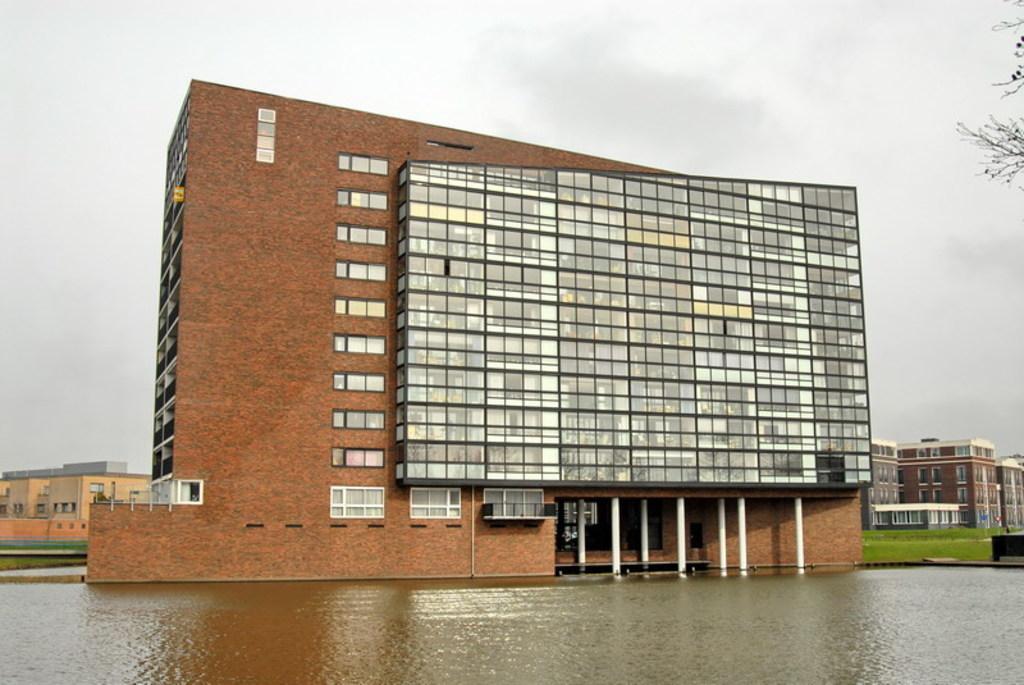Can you describe this image briefly? In this picture we can see water at the bottom, in the background there are some buildings, we can see windows and glasses of these buildings, on the right side there is grass, we can see branches of the tree at the right top, there are some pillars of the building in the middle, we can see the sky at the top of the picture. 